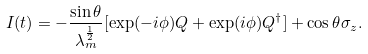<formula> <loc_0><loc_0><loc_500><loc_500>I ( t ) = - \frac { \sin \theta } { \lambda _ { m } ^ { \frac { 1 } { 2 } } } [ \exp ( - i \phi ) Q + \exp ( i \phi ) Q ^ { \dagger } ] + \cos \theta \sigma _ { z } .</formula> 